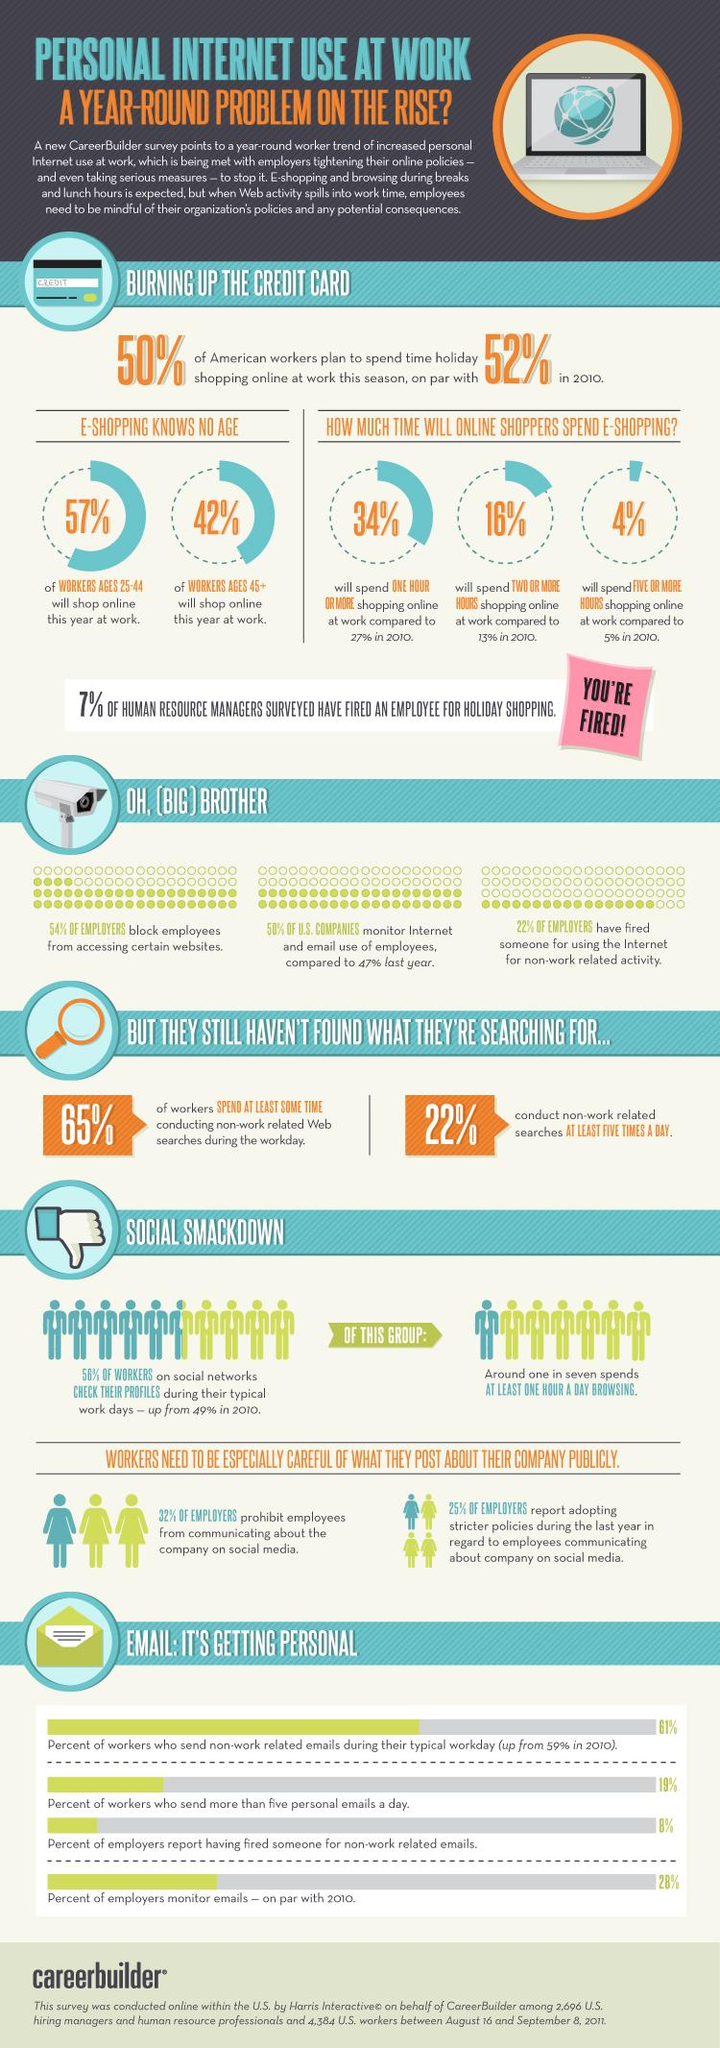Indicate a few pertinent items in this graphic. According to the data, 68% of employers allow their employees to communicate about the company on social media. According to a survey, 46% of employers allow their employees to access certain websites. 